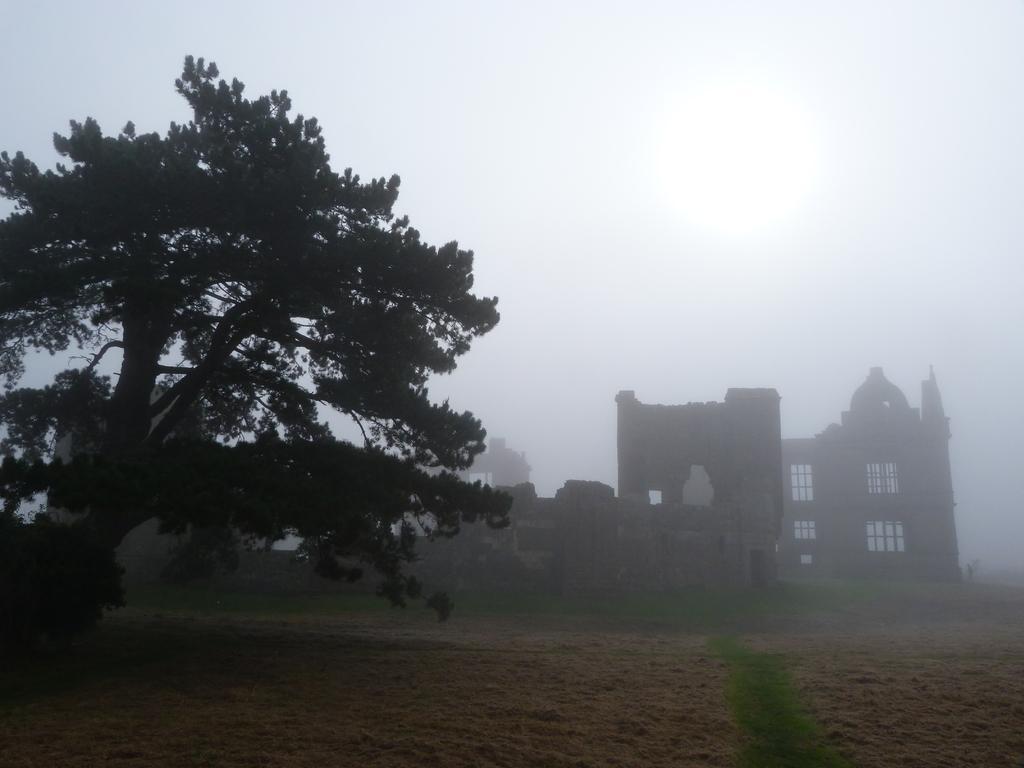Describe this image in one or two sentences. There are trees and buildings at the back. 